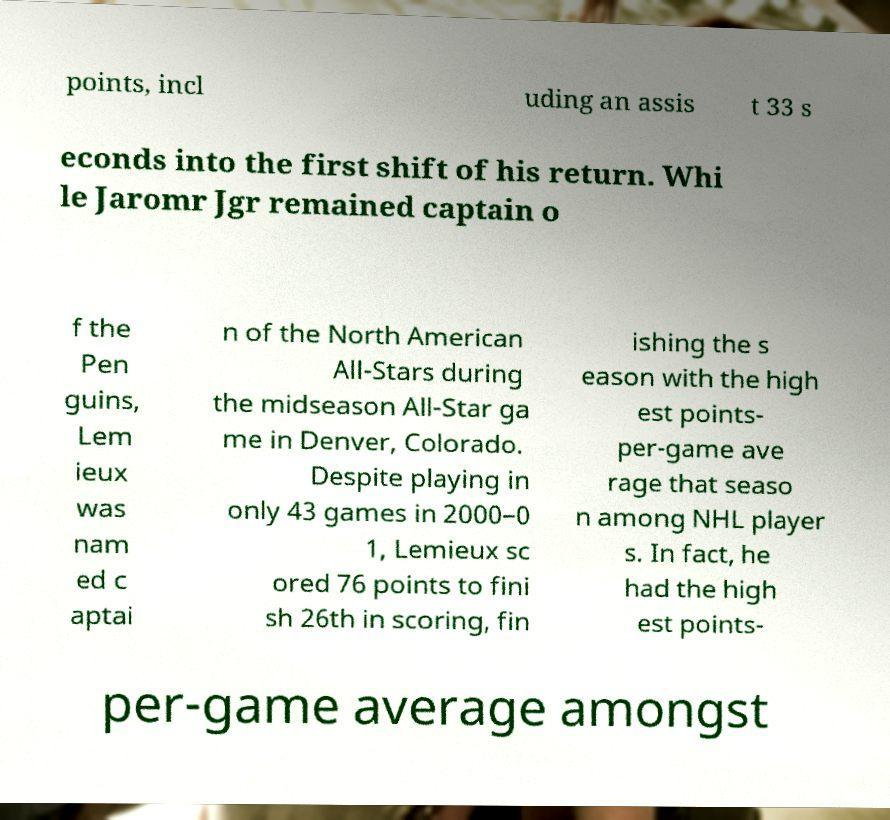Please identify and transcribe the text found in this image. points, incl uding an assis t 33 s econds into the first shift of his return. Whi le Jaromr Jgr remained captain o f the Pen guins, Lem ieux was nam ed c aptai n of the North American All-Stars during the midseason All-Star ga me in Denver, Colorado. Despite playing in only 43 games in 2000–0 1, Lemieux sc ored 76 points to fini sh 26th in scoring, fin ishing the s eason with the high est points- per-game ave rage that seaso n among NHL player s. In fact, he had the high est points- per-game average amongst 